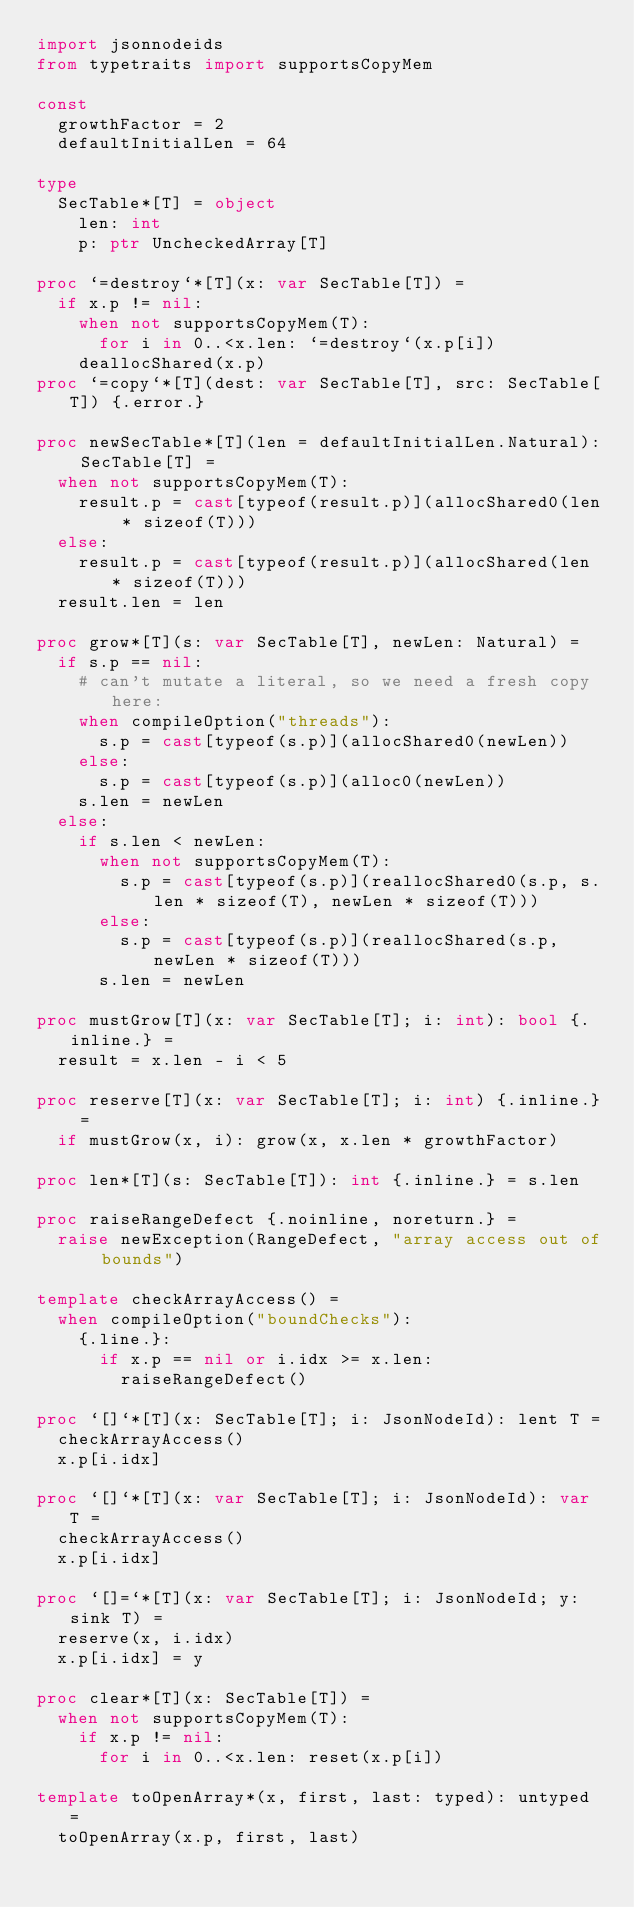<code> <loc_0><loc_0><loc_500><loc_500><_Nim_>import jsonnodeids
from typetraits import supportsCopyMem

const
  growthFactor = 2
  defaultInitialLen = 64

type
  SecTable*[T] = object
    len: int
    p: ptr UncheckedArray[T]

proc `=destroy`*[T](x: var SecTable[T]) =
  if x.p != nil:
    when not supportsCopyMem(T):
      for i in 0..<x.len: `=destroy`(x.p[i])
    deallocShared(x.p)
proc `=copy`*[T](dest: var SecTable[T], src: SecTable[T]) {.error.}

proc newSecTable*[T](len = defaultInitialLen.Natural): SecTable[T] =
  when not supportsCopyMem(T):
    result.p = cast[typeof(result.p)](allocShared0(len * sizeof(T)))
  else:
    result.p = cast[typeof(result.p)](allocShared(len * sizeof(T)))
  result.len = len

proc grow*[T](s: var SecTable[T], newLen: Natural) =
  if s.p == nil:
    # can't mutate a literal, so we need a fresh copy here:
    when compileOption("threads"):
      s.p = cast[typeof(s.p)](allocShared0(newLen))
    else:
      s.p = cast[typeof(s.p)](alloc0(newLen))
    s.len = newLen
  else:
    if s.len < newLen:
      when not supportsCopyMem(T):
        s.p = cast[typeof(s.p)](reallocShared0(s.p, s.len * sizeof(T), newLen * sizeof(T)))
      else:
        s.p = cast[typeof(s.p)](reallocShared(s.p, newLen * sizeof(T)))
      s.len = newLen

proc mustGrow[T](x: var SecTable[T]; i: int): bool {.inline.} =
  result = x.len - i < 5

proc reserve[T](x: var SecTable[T]; i: int) {.inline.} =
  if mustGrow(x, i): grow(x, x.len * growthFactor)

proc len*[T](s: SecTable[T]): int {.inline.} = s.len

proc raiseRangeDefect {.noinline, noreturn.} =
  raise newException(RangeDefect, "array access out of bounds")

template checkArrayAccess() =
  when compileOption("boundChecks"):
    {.line.}:
      if x.p == nil or i.idx >= x.len:
        raiseRangeDefect()

proc `[]`*[T](x: SecTable[T]; i: JsonNodeId): lent T =
  checkArrayAccess()
  x.p[i.idx]

proc `[]`*[T](x: var SecTable[T]; i: JsonNodeId): var T =
  checkArrayAccess()
  x.p[i.idx]

proc `[]=`*[T](x: var SecTable[T]; i: JsonNodeId; y: sink T) =
  reserve(x, i.idx)
  x.p[i.idx] = y

proc clear*[T](x: SecTable[T]) =
  when not supportsCopyMem(T):
    if x.p != nil:
      for i in 0..<x.len: reset(x.p[i])

template toOpenArray*(x, first, last: typed): untyped =
  toOpenArray(x.p, first, last)
</code> 